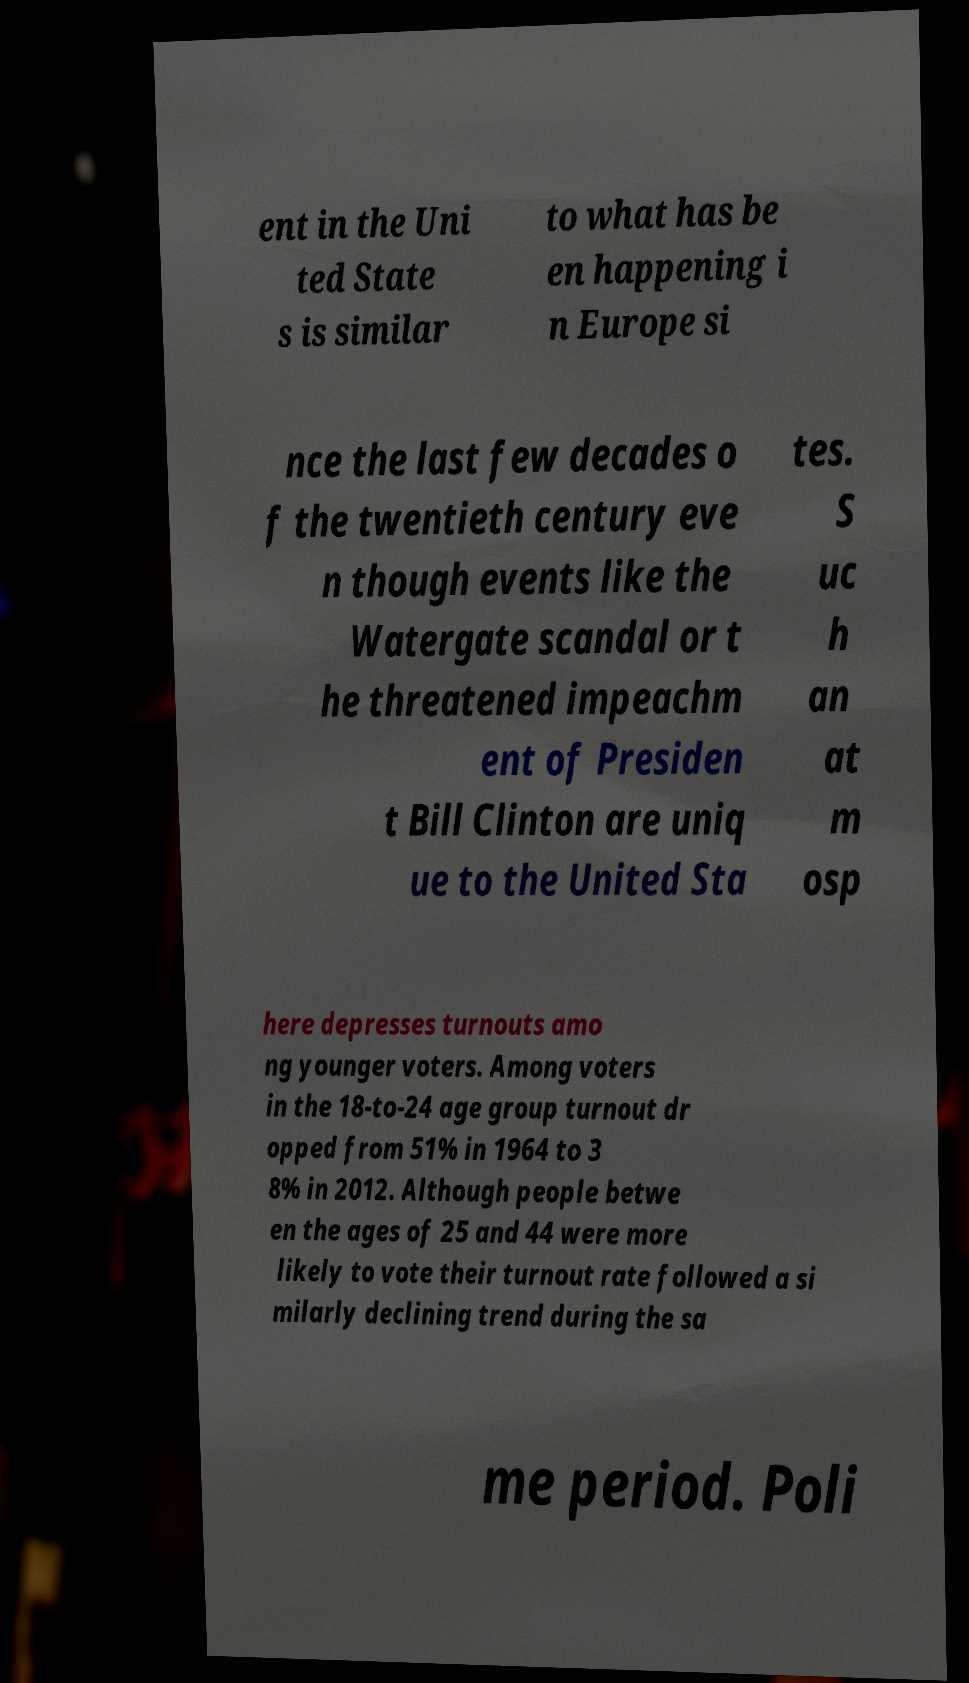Please read and relay the text visible in this image. What does it say? ent in the Uni ted State s is similar to what has be en happening i n Europe si nce the last few decades o f the twentieth century eve n though events like the Watergate scandal or t he threatened impeachm ent of Presiden t Bill Clinton are uniq ue to the United Sta tes. S uc h an at m osp here depresses turnouts amo ng younger voters. Among voters in the 18-to-24 age group turnout dr opped from 51% in 1964 to 3 8% in 2012. Although people betwe en the ages of 25 and 44 were more likely to vote their turnout rate followed a si milarly declining trend during the sa me period. Poli 